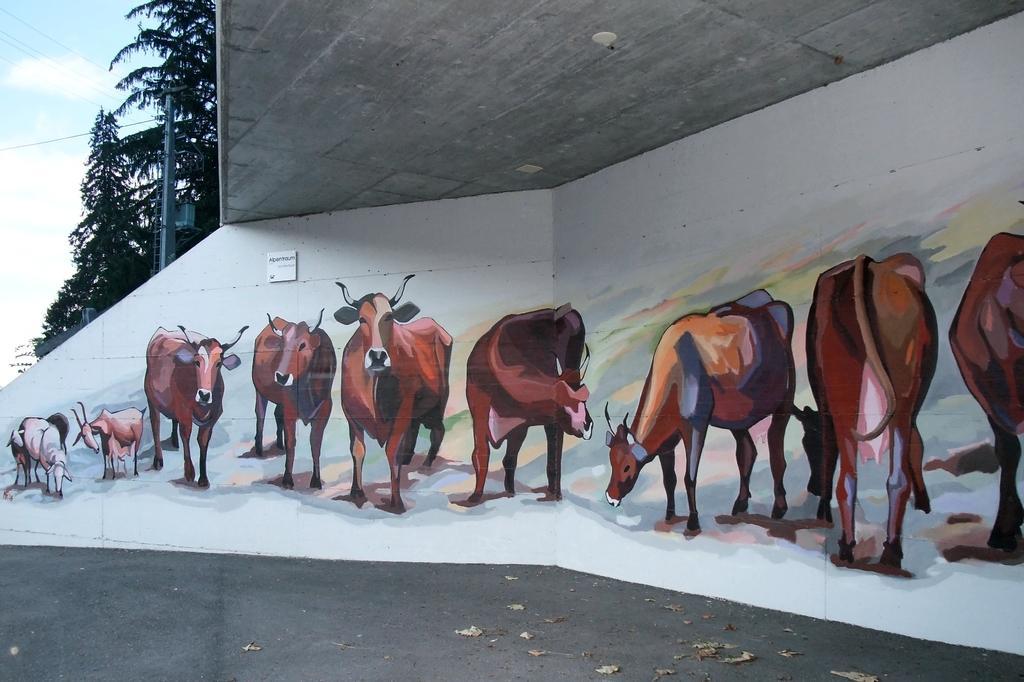Please provide a concise description of this image. In this image we can painting of animals on the wall. At the bottom we can see leaves on the road. In the background we can see trees, objects on a pole, wires, roof and clouds in the sky. 